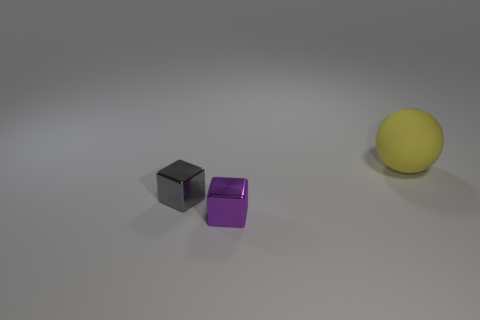Add 3 large gray rubber cylinders. How many objects exist? 6 Subtract all purple cubes. How many cubes are left? 1 Subtract all cubes. How many objects are left? 1 Subtract 1 balls. How many balls are left? 0 Subtract 0 blue blocks. How many objects are left? 3 Subtract all blue spheres. Subtract all red cylinders. How many spheres are left? 1 Subtract all gray metal cylinders. Subtract all large rubber spheres. How many objects are left? 2 Add 2 tiny purple cubes. How many tiny purple cubes are left? 3 Add 2 metallic blocks. How many metallic blocks exist? 4 